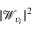<formula> <loc_0><loc_0><loc_500><loc_500>| \mathcal { W } _ { v _ { i } } | ^ { 2 }</formula> 